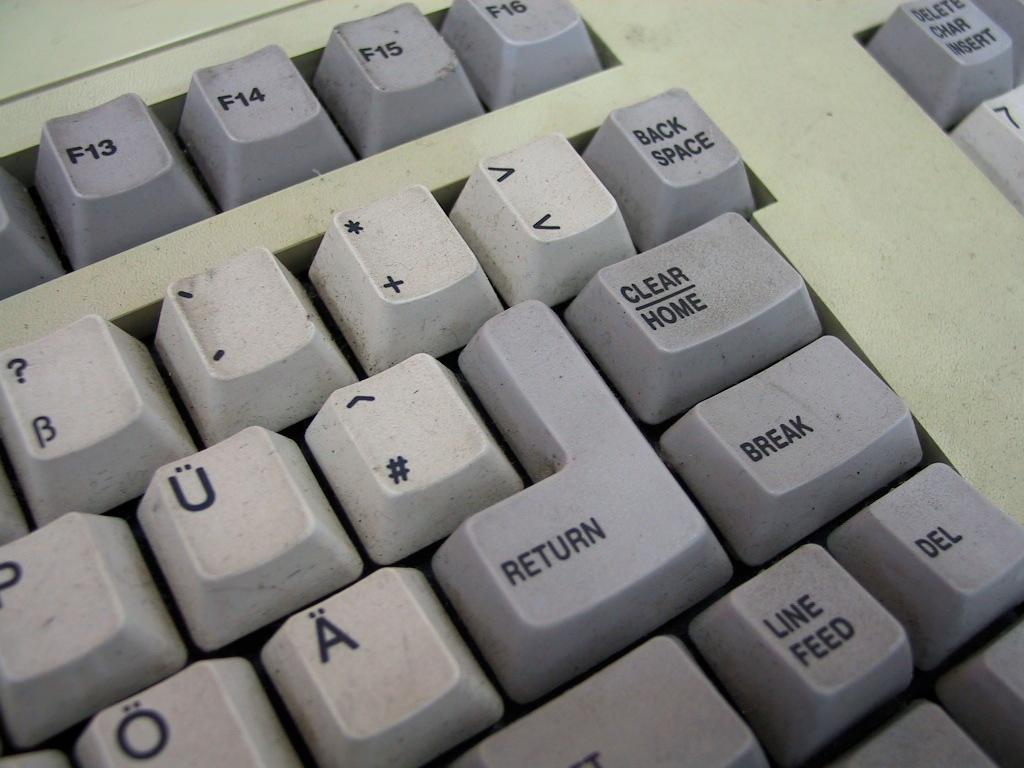Provide a one-sentence caption for the provided image. The right side of a keyboard, and the delete button is next to the line feed button. 